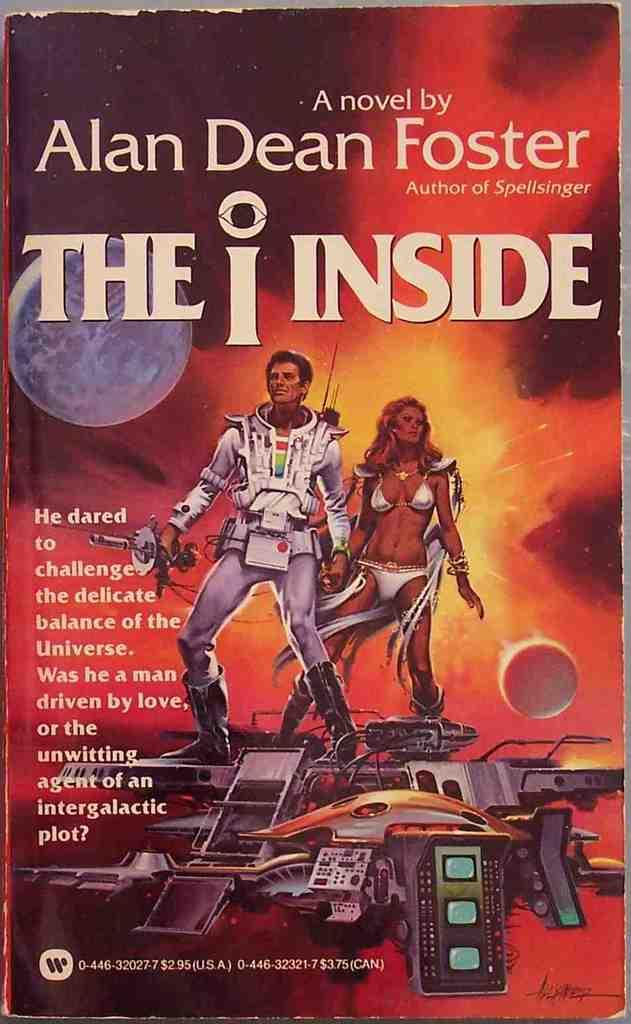<image>
Give a short and clear explanation of the subsequent image. Book Cover that says A novel by Alan Dean Foster The Inside. 